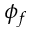Convert formula to latex. <formula><loc_0><loc_0><loc_500><loc_500>\phi _ { f }</formula> 